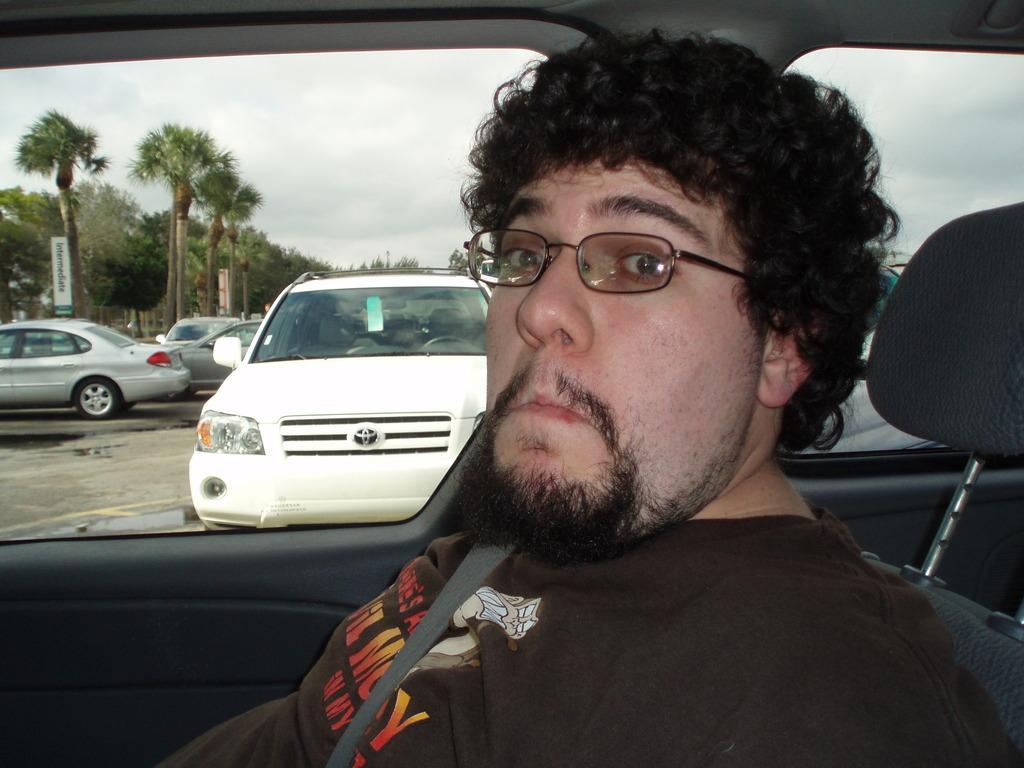Please provide a concise description of this image. This image is taken inside a car. In this image a man is sitting in the car and through the window of the car we can see few vehicles and at the background there is a sky with clouds and there were many trees. 